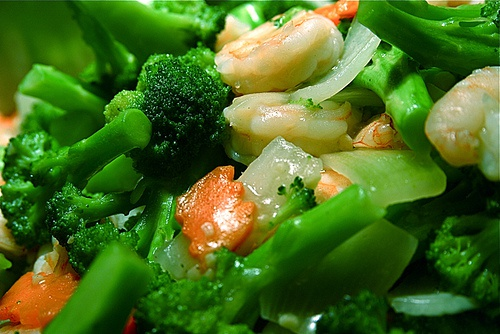Describe the objects in this image and their specific colors. I can see broccoli in darkgreen and green tones, broccoli in darkgreen and green tones, broccoli in darkgreen, black, and green tones, broccoli in darkgreen and green tones, and broccoli in darkgreen, black, and green tones in this image. 